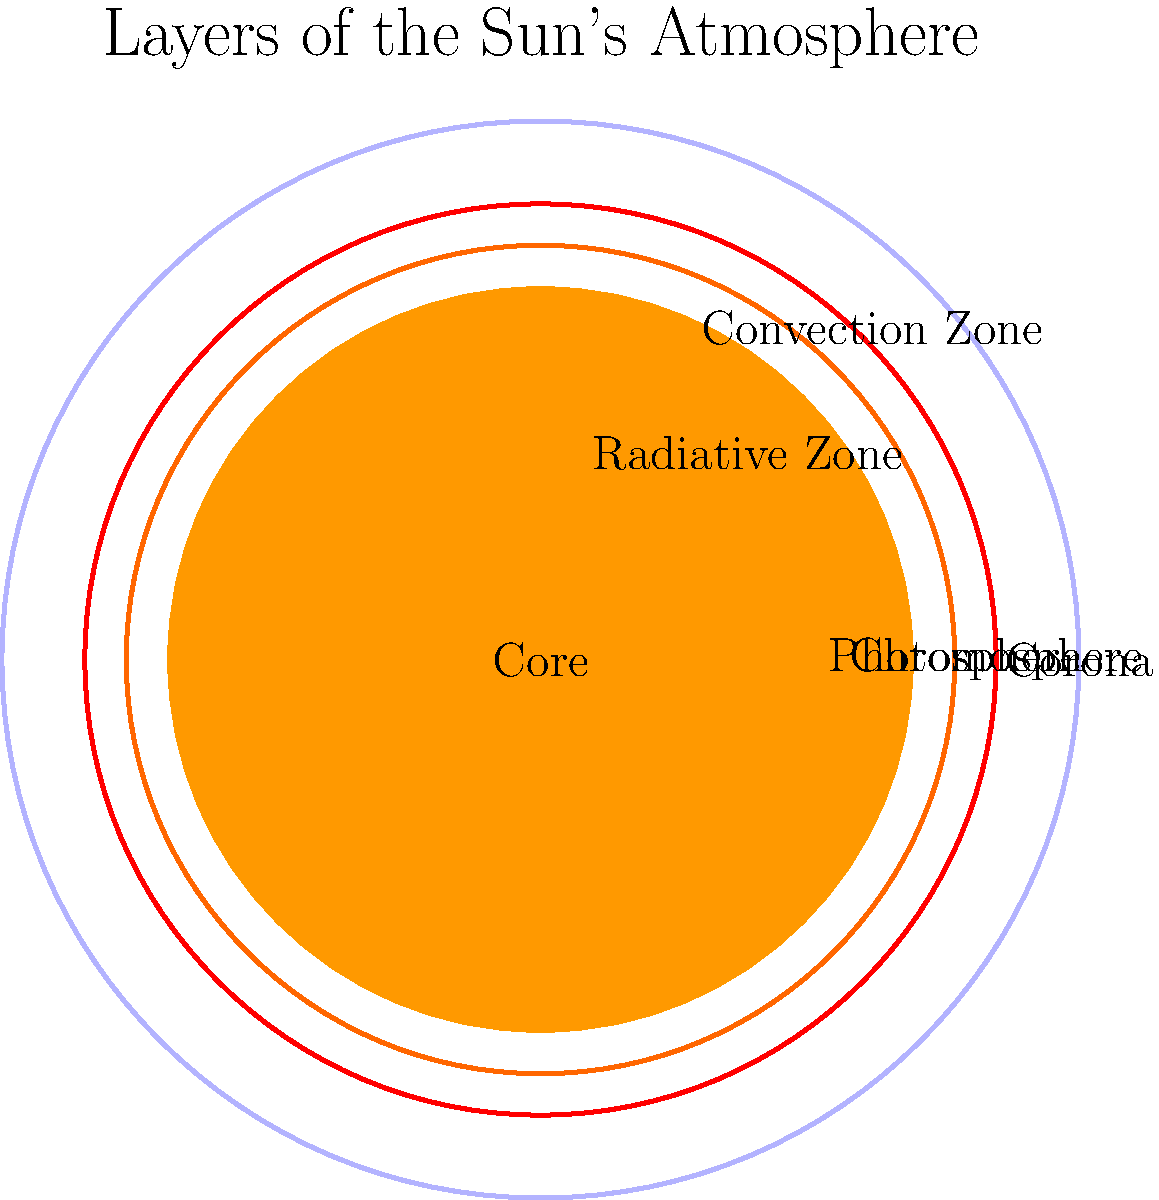In the realm of pulp-inspired cosmic adventures, your protagonist encounters a mysterious alien artifact that reveals secrets about the Sun's atmosphere. Which layer of the Sun's atmosphere, as shown in the cross-section, would be most suitable for a thrilling space battle scene, considering it's the hottest and most extensive layer, perfect for dramatic tension? To answer this question, let's analyze the layers of the Sun's atmosphere as shown in the cross-section:

1. Core: The innermost layer, where nuclear fusion occurs. Not part of the atmosphere.

2. Radiative Zone: The layer surrounding the core, where energy is transferred by radiation. Not part of the atmosphere.

3. Convection Zone: The outermost layer of the Sun's interior, where energy is transferred by convection. Not part of the atmosphere.

4. Photosphere: The visible surface of the Sun, often considered the first layer of the atmosphere. However, it's relatively cool compared to other atmospheric layers.

5. Chromosphere: A thin layer above the photosphere, hotter than the photosphere but cooler than the corona.

6. Corona: The outermost layer of the Sun's atmosphere. It has two key characteristics that make it ideal for a thrilling space battle scene:

   a) Temperature: The corona is extremely hot, with temperatures reaching millions of degrees Celsius. This extreme heat adds an element of danger and excitement to the scene.
   
   b) Extent: The corona extends far into space, much farther than other layers. This vast expanse provides ample room for epic space battles and dramatic maneuvers.

Given these characteristics, the corona would be the most suitable layer for a thrilling space battle scene in a pulp-inspired cosmic adventure.
Answer: Corona 